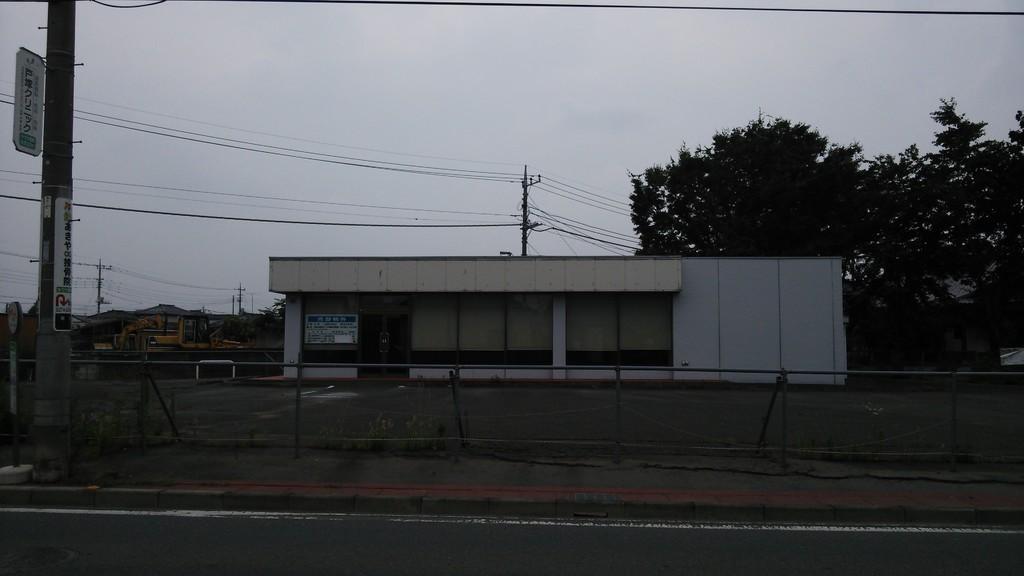In one or two sentences, can you explain what this image depicts? In the picture there is a compartment and in front of that there is a road and on the left side there is a pole,behind that there is an electric pole there are many wires attached to that, on the right side there are some trees. 